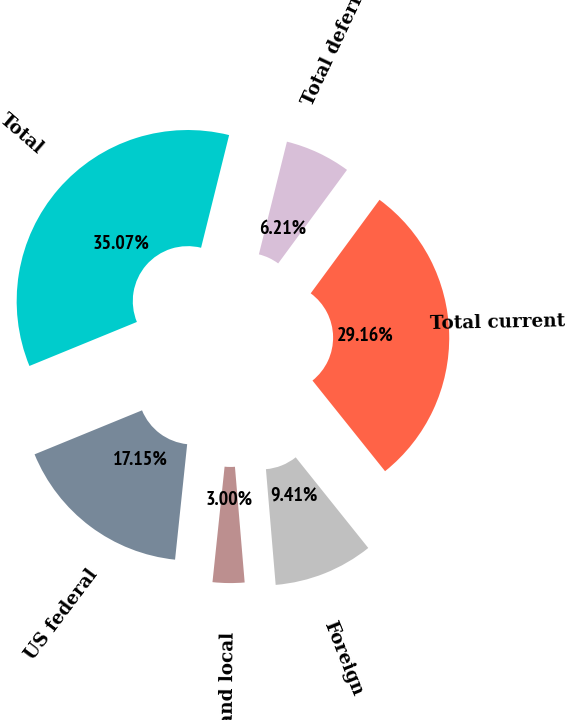Convert chart. <chart><loc_0><loc_0><loc_500><loc_500><pie_chart><fcel>US federal<fcel>State and local<fcel>Foreign<fcel>Total current<fcel>Total deferred<fcel>Total<nl><fcel>17.15%<fcel>3.0%<fcel>9.41%<fcel>29.16%<fcel>6.21%<fcel>35.07%<nl></chart> 